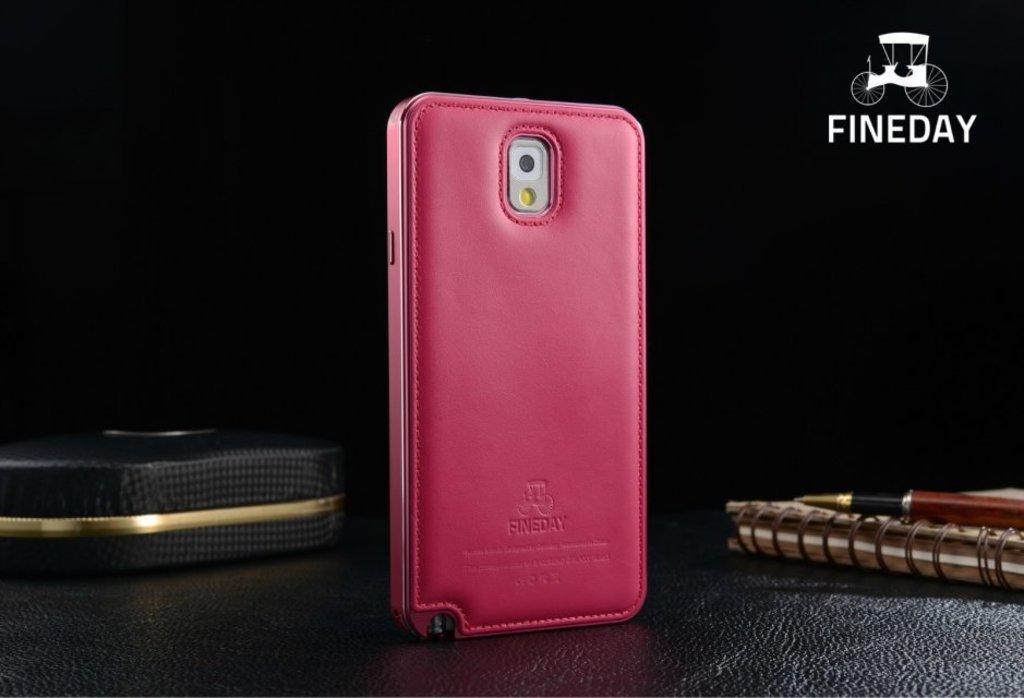Please provide a concise description of this image. In this image we can see black surface. On that there is a book with pen, mobile case and a box. Also we can see watermark in the right top corner. 